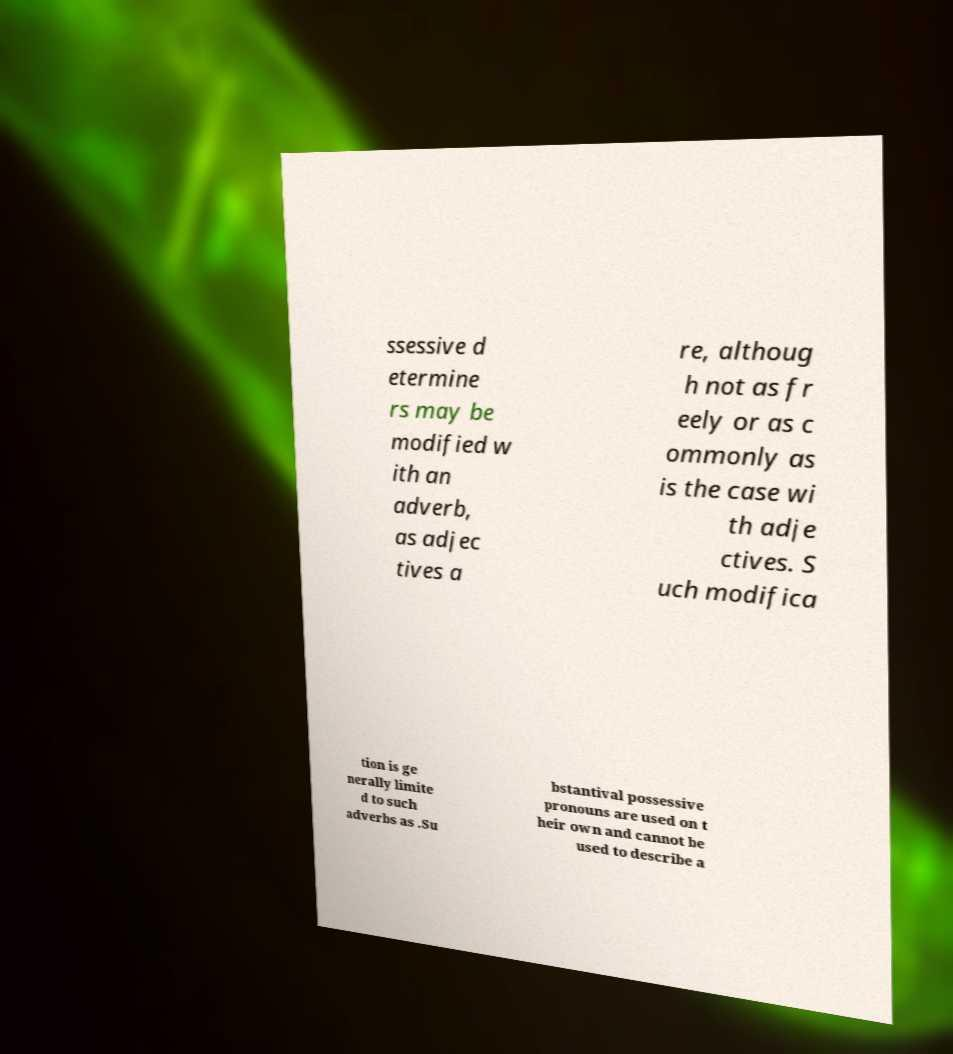Could you assist in decoding the text presented in this image and type it out clearly? ssessive d etermine rs may be modified w ith an adverb, as adjec tives a re, althoug h not as fr eely or as c ommonly as is the case wi th adje ctives. S uch modifica tion is ge nerally limite d to such adverbs as .Su bstantival possessive pronouns are used on t heir own and cannot be used to describe a 